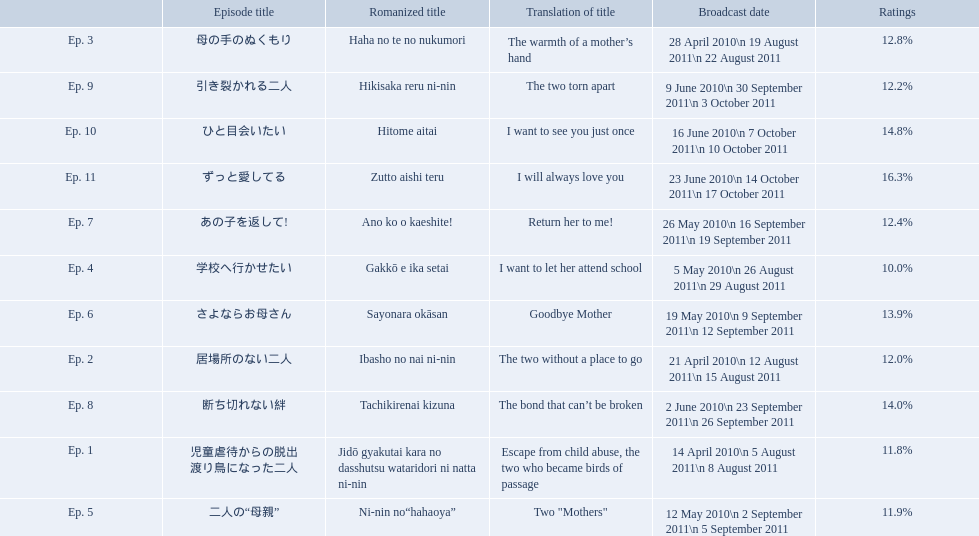How many total episodes are there? Ep. 1, Ep. 2, Ep. 3, Ep. 4, Ep. 5, Ep. 6, Ep. 7, Ep. 8, Ep. 9, Ep. 10, Ep. 11. Of those episodes, which one has the title of the bond that can't be broken? Ep. 8. What was the ratings percentage for that episode? 14.0%. 